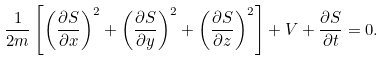Convert formula to latex. <formula><loc_0><loc_0><loc_500><loc_500>\frac { 1 } { 2 m } \left [ \left ( \frac { \partial S } { \partial x } \right ) ^ { 2 } + \left ( \frac { \partial S } { \partial y } \right ) ^ { 2 } + \left ( \frac { \partial S } { \partial z } \right ) ^ { 2 } \right ] + V + \frac { \partial S } { \partial t } = 0 .</formula> 